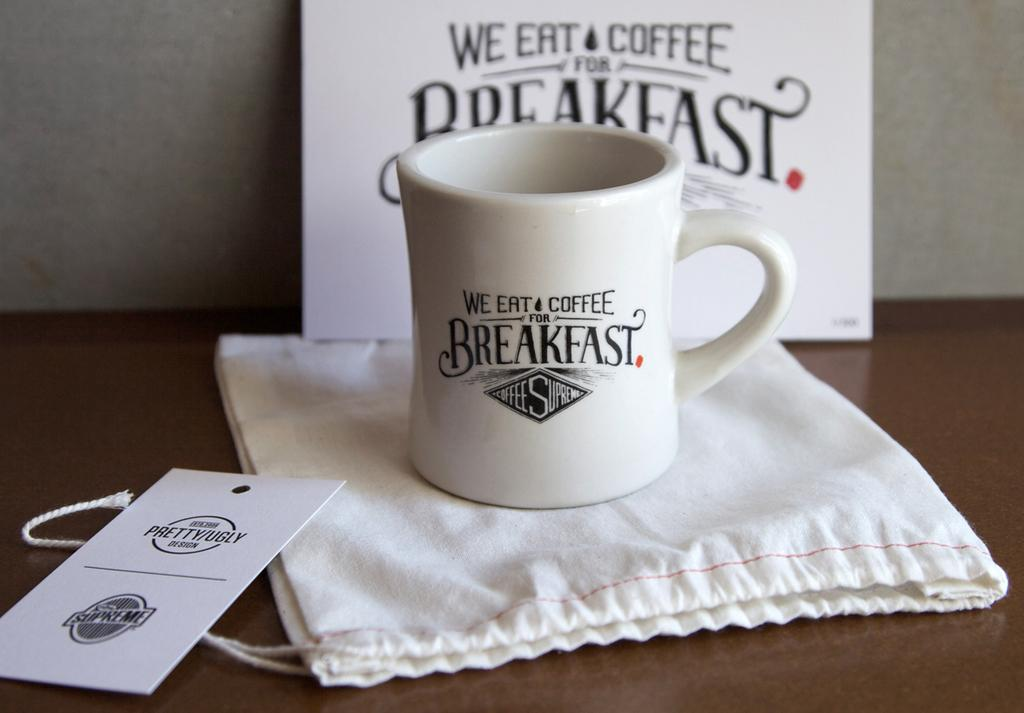<image>
Render a clear and concise summary of the photo. A white mug on a table that says We eat coffee Breakfast. 